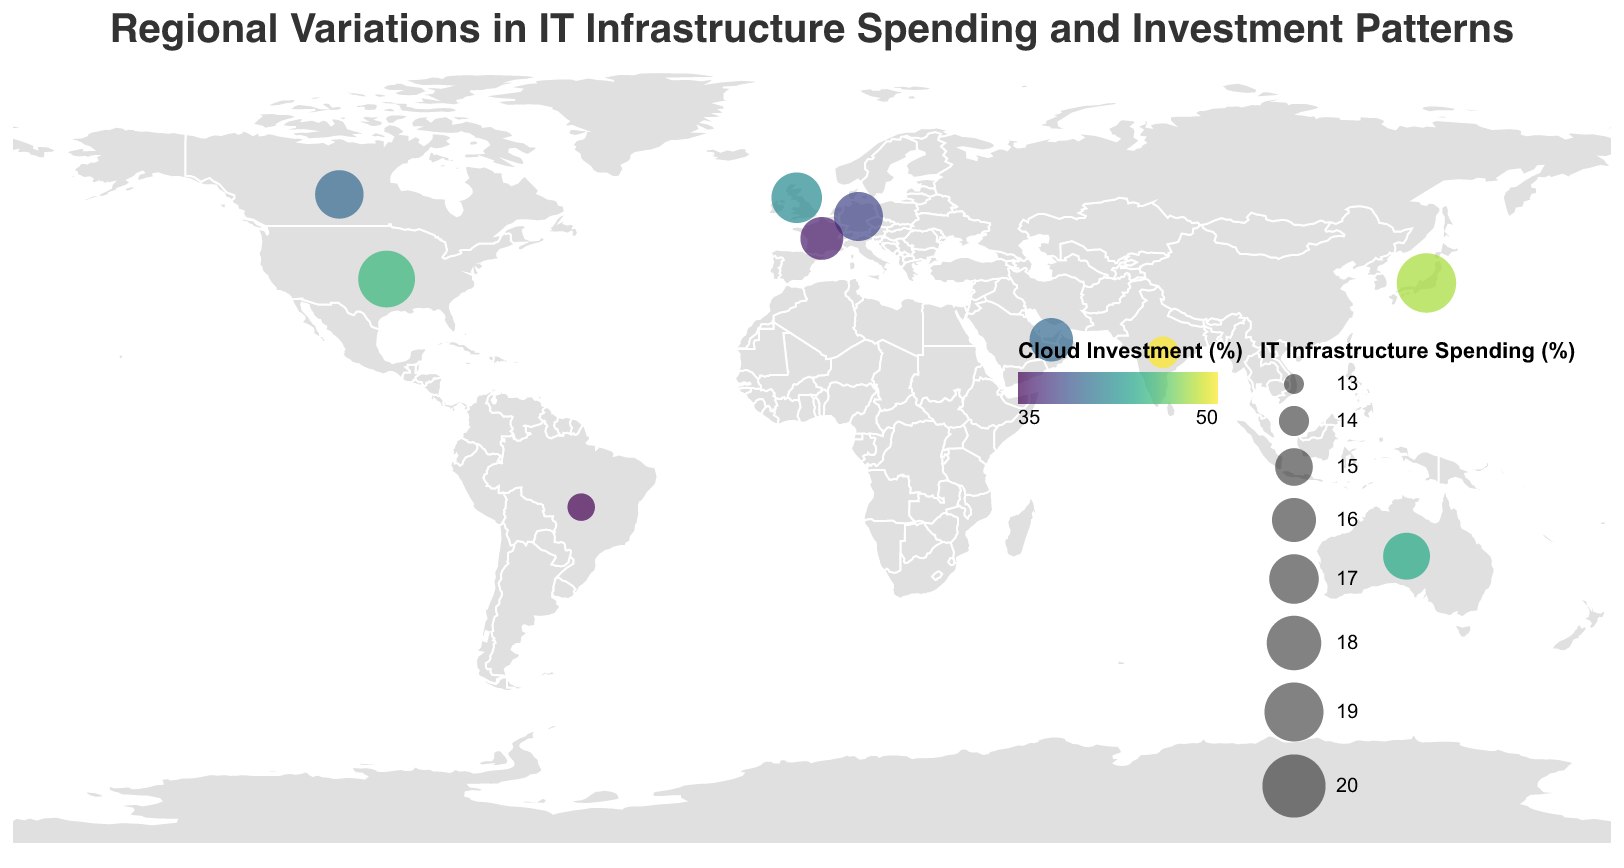What is the title of the figure? The title of the figure is prominently displayed at the top of the plot. It reads "Regional Variations in IT Infrastructure Spending and Investment Patterns."
Answer: Regional Variations in IT Infrastructure Spending and Investment Patterns Which country has the highest percentage of Cloud Investment? By looking at the color of the circles, the country with the deepest color (indicating the highest Cloud Investment percentage) is India.
Answer: India What is the IT Infrastructure Spending percentage for Japan? The size of the circle over Japan indicates the IT Infrastructure Spending percentage. By referring to the legend on the bottom right, the approximate size corresponds to 19.1%.
Answer: 19.1% Among European countries listed, which one has the highest percentage of On-Premise Investment? Comparing the On-Premise Investment percentages for the UK, Germany, and France, France has the highest percentage of 42%.
Answer: France Compare the IT Infrastructure Spending percentages between Brazil and the UAE. Which is higher? The size of the circles shows IT Infrastructure Spending percentages. The UAE circle is larger than Brazil, indicating that the UAE has a higher percentage.
Answer: UAE Rank the regions (North America, Europe, Asia Pacific, South America, Middle East) based on the average IT Infrastructure Spending percentage from highest to lowest. Calculate the average IT Infrastructure Spending percentage for each region: North America (17.65), Europe (16.63), Asia Pacific (16.6), Middle East (15.9), South America (13.7). Thus, from highest to lowest: North America, Europe, Asia Pacific, Middle East, South America.
Answer: North America, Europe, Asia Pacific, Middle East, South America Which countries have the same percentage of Cybersecurity Investment? By checking the Cybersecurity Investment percentages, the United States, Japan, India, and Brazil all have 20%, while Canada, UK, Germany, France, Australia, and UAE have 22%.
Answer: United States, Japan, India, Brazil (20%); Canada, UK, Germany, France, Australia, UAE (22%) In terms of IT Infrastructure Spending, which country in North America spends less, the United States or Canada? The United States has an IT Infrastructure Spending percentage of 18.5%, while Canada has 16.8%. Therefore, Canada spends less.
Answer: Canada How does the investment pattern in Cloud and On-Premise differ between Germany and Australia? Germany has a Cloud Investment of 38% and On-Premise 40%, while Australia has a Cloud Investment of 44% and On-Premise 34%. Germany spends more on On-Premise whereas Australia invests more in Cloud.
Answer: Germany: More on On-Premise, Australia: More on Cloud Identify the country with the largest circle and specify its significance. The largest circle represents the highest IT Infrastructure Spending percentage. By visual inspection, the largest circle is over Japan, which signifies the highest percentage of 19.1%.
Answer: Japan (19.1%) 